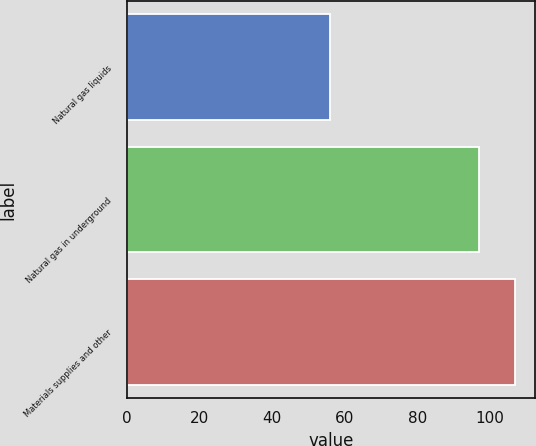<chart> <loc_0><loc_0><loc_500><loc_500><bar_chart><fcel>Natural gas liquids<fcel>Natural gas in underground<fcel>Materials supplies and other<nl><fcel>56<fcel>97<fcel>107<nl></chart> 